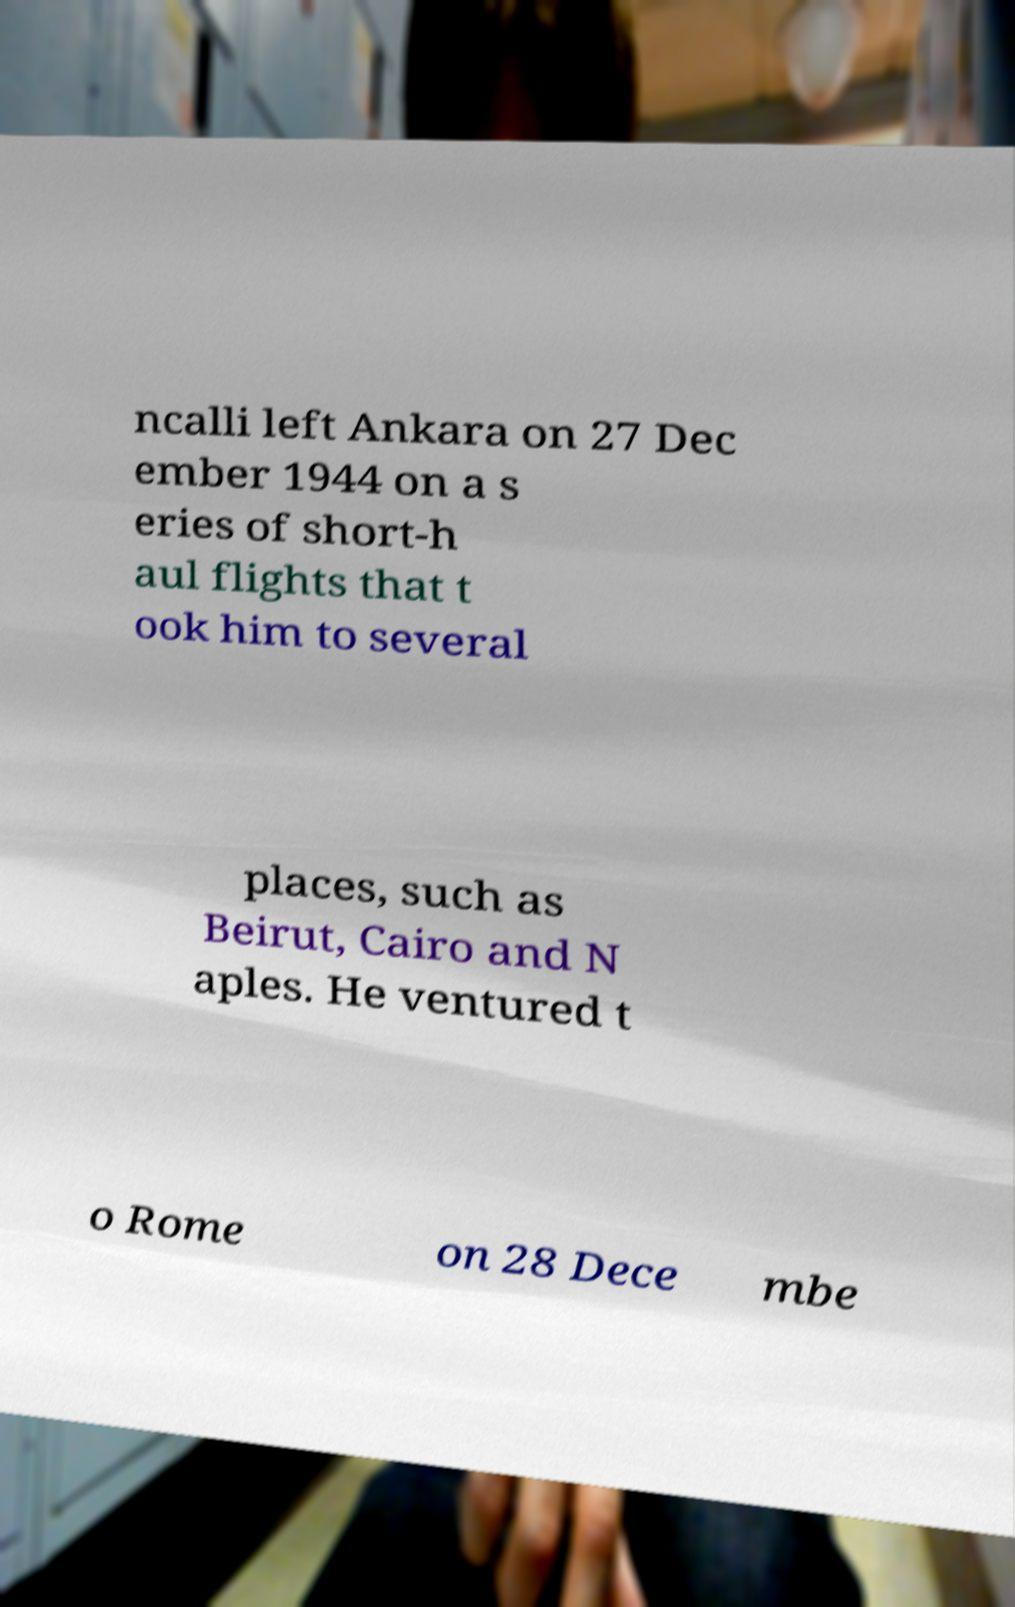Can you accurately transcribe the text from the provided image for me? ncalli left Ankara on 27 Dec ember 1944 on a s eries of short-h aul flights that t ook him to several places, such as Beirut, Cairo and N aples. He ventured t o Rome on 28 Dece mbe 